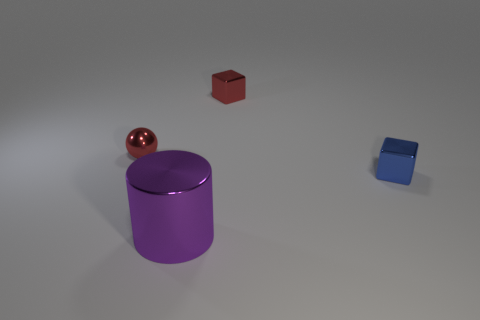Add 2 blue metallic cubes. How many objects exist? 6 Subtract all cylinders. How many objects are left? 3 Add 3 tiny red balls. How many tiny red balls are left? 4 Add 4 small blue objects. How many small blue objects exist? 5 Subtract 0 brown cylinders. How many objects are left? 4 Subtract all tiny green metallic spheres. Subtract all purple shiny cylinders. How many objects are left? 3 